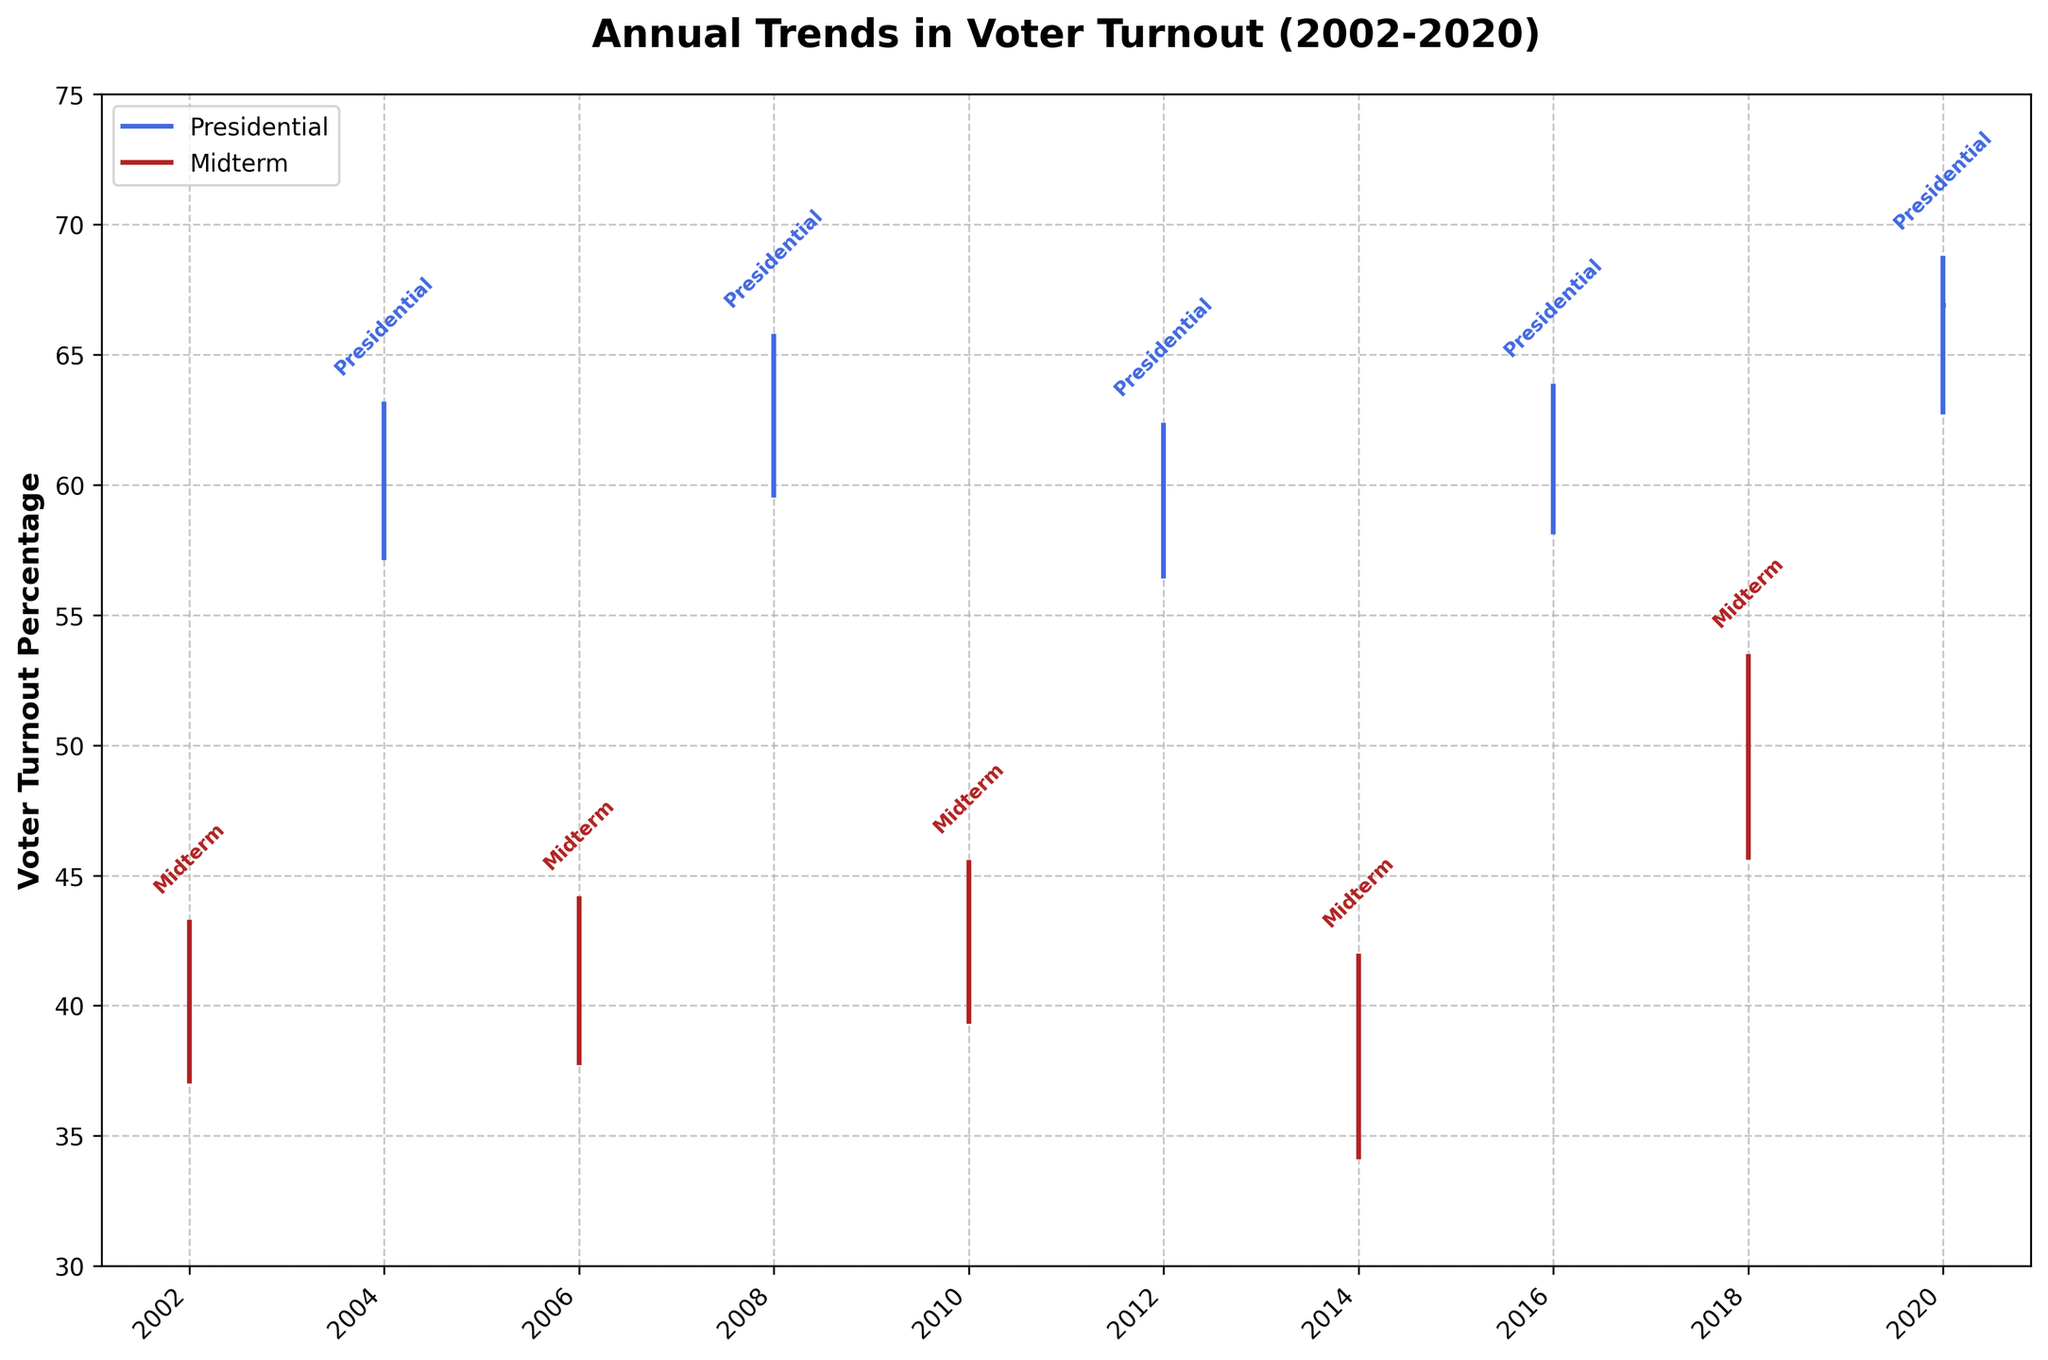What is the title of the figure? The title of the figure is typically placed at the top and describes what the chart is showing. In this case, the title is "Annual Trends in Voter Turnout (2002-2020)."
Answer: Annual Trends in Voter Turnout (2002-2020) What is the color used to represent the Presidential elections? The figure uses distinct colors for different election types. By looking at the plot and the legend, the color for Presidential elections is royal blue.
Answer: royal blue What is the highest voter turnout percentage for Midterm elections shown in the figure? To find the highest voter turnout for Midterm elections, look for the tallest bar among the red-colored lines. The highest recorded is for 2018 at 53.4%.
Answer: 53.4% Which year had the lowest final voter turnout percentage for Presidential elections? Review the blue lines representing the Presidential elections and identify the lowest final tick mark among them. The lowest final turnout for Presidential elections is in 2012 at 60.1%.
Answer: 2012 How did the voter turnout percentages vary for Midterm and Presidential elections in 2010 and 2012, respectively? Compare the initial, highest, lowest, and final percentages for the years 2010 and 2012. For 2010 (Midterm): Initial - 41.8%, Highest - 45.5%, Lowest - 39.4%, Final - 42.9%. For 2012 (Presidential): Initial - 58.9%, Highest - 62.3%, Lowest - 56.5%, Final - 60.1%.
Answer: 2010: 41.8%, 45.5%, 39.4%, 42.9%; 2012: 58.9%, 62.3%, 56.5%, 60.1% Which election type in 2014 showed a greater initial voter turnout compared to the lowest point of the Presidential election in the same period? Review the figure for 2014, focusing on the initial value of Midterm elections and the lowest value of Presidential elections. Midterm initial in 2014 is 36.7%, while the lowest for Presidential in 2016 is 58.2%. Clearly, Presidential elections' lowest turnout in 2016 is higher than Midterm in 2014.
Answer: Presidential What is the difference between the highest voter turnout in 2008 and the lowest voter turnout in 2014? Identify the highest turnout in 2008 (65.7%) and the lowest in 2014 (34.2%). Subtract the lowest from the highest: 65.7% - 34.2% = 31.5%.
Answer: 31.5% What pattern can be observed in voter turnout percentages between Presidential and Midterm elections from 2002 to 2020? Look at the overall trends for both types of elections. Generally, presidential elections show higher voter turnout percentages compared to midterm elections across the years.
Answer: Presidential elections have higher turnout How did voter participation change from the initial to the final point in 2018 Midterm elections? Check the initial and final marks for 2018 Midterm elections. Initial: 48.1%, Final: 50.3%. The change is 50.3% - 48.1% = 2.2%.
Answer: Increased by 2.2% 